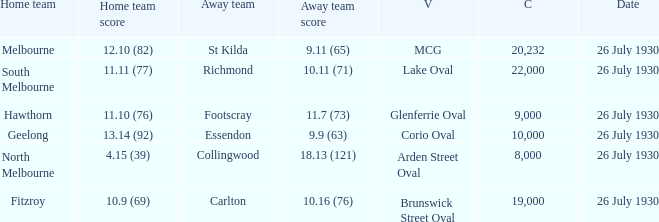When was Fitzroy the home team? 26 July 1930. 